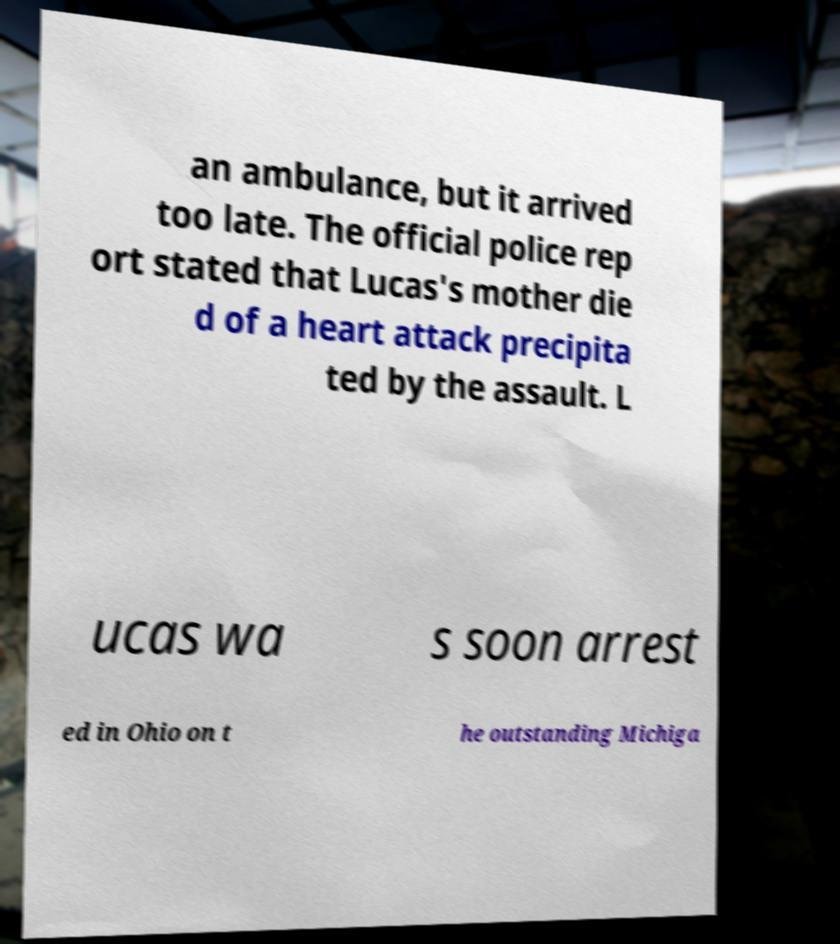Can you accurately transcribe the text from the provided image for me? an ambulance, but it arrived too late. The official police rep ort stated that Lucas's mother die d of a heart attack precipita ted by the assault. L ucas wa s soon arrest ed in Ohio on t he outstanding Michiga 